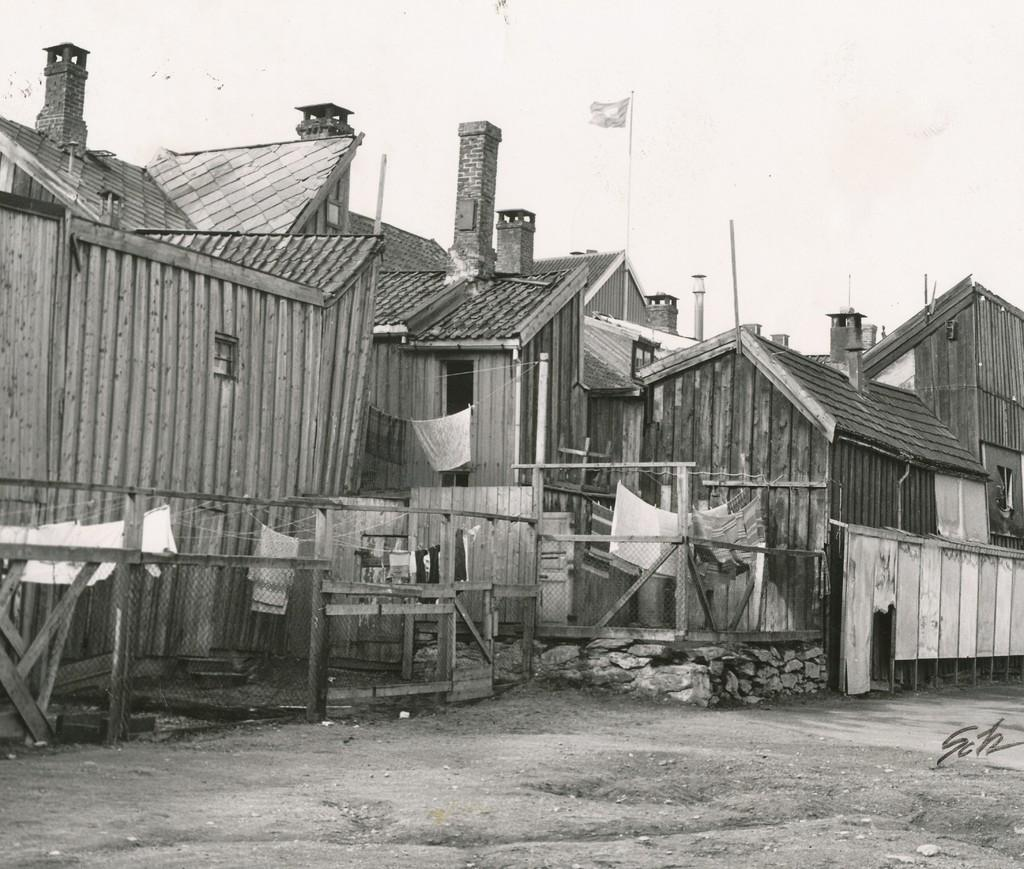What type of houses can be seen in the image? There are wooden houses in the image. What structure is present in the image besides the houses? There is a flag pole in the image. What activity is being done with the clothes in the image? The clothes are hung on ropes in the image. How would you describe the weather in the image? The sky is cloudy in the image. Where is the volcano located in the image? There is no volcano present in the image. What type of tool is being used to fix the clothesline in the image? There is no tool visible in the image, and the clothes are simply hung on ropes. 